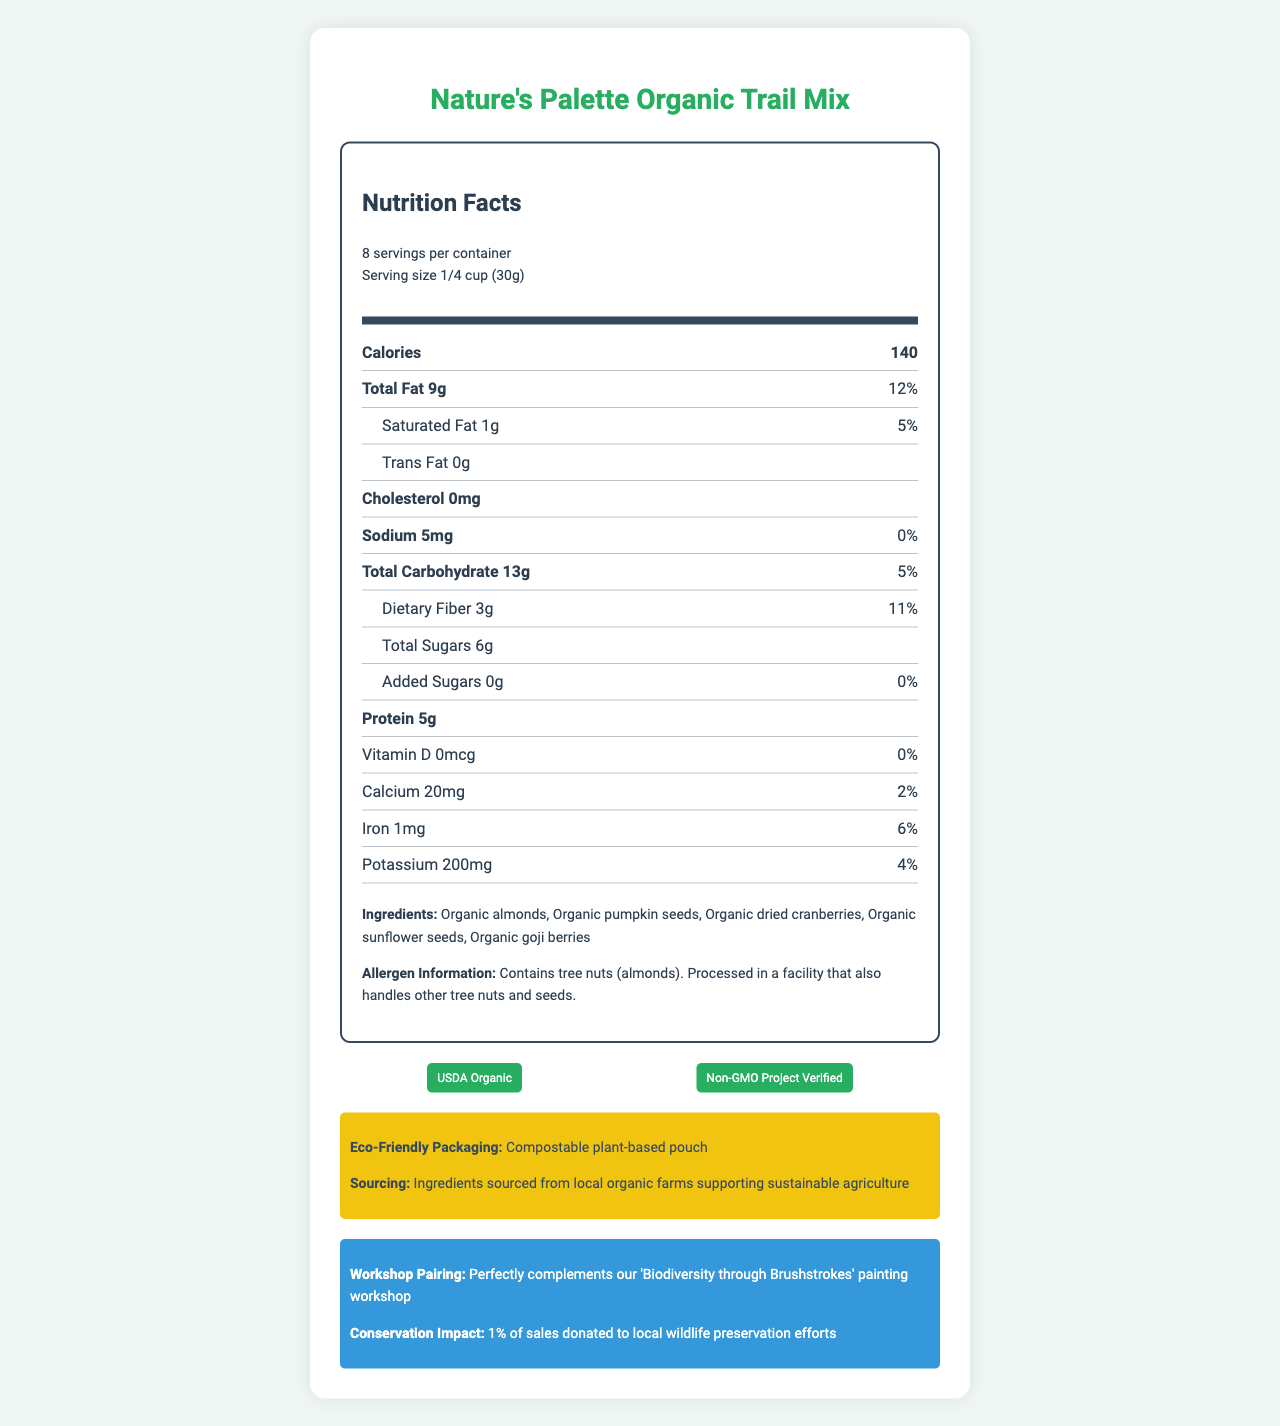what is the serving size? The serving size is listed at the beginning of the nutrition information under the product name.
Answer: 1/4 cup (30g) how many servings are in one container? The number of servings per container is listed in the serving information.
Answer: 8 how many grams of protein are in one serving? The protein content per serving is listed in the nutrition facts section.
Answer: 5g what percentage of the daily value of total fat is in one serving? The percentage of the daily value for total fat is listed in the nutrition facts section next to the amount.
Answer: 12% is there any cholesterol in the product? The nutrition facts state that cholesterol is 0mg.
Answer: No what are the ingredients in this trail mix? The ingredients are listed toward the bottom of the document under the ingredients section.
Answer: Organic almonds, Organic pumpkin seeds, Organic dried cranberries, Organic sunflower seeds, Organic goji berries which of the following nutrients has the highest daily value percentage per serving? A. Saturated Fat B. Dietary Fiber C. Potassium D. Iron Dietary Fiber has a daily value percentage of 11%, which is higher than the other listed nutrients.
Answer: A. Dietary Fiber how much calcium does one serving provide? A. 0mg B. 10mg C. 20mg D. 30mg The nutrition facts section lists the calcium content, which is 20mg per serving.
Answer: C. 20mg what certifications does this product have? The certifications are listed at the bottom of the document in the certifications section.
Answer: USDA Organic, Non-GMO Project Verified does this product contain added sugars? The document states that added sugars are 0g.
Answer: No is the packaging eco-friendly? The document mentions that the product comes in a compostable plant-based pouch in the eco-friendly packaging section.
Answer: Yes how much potassium is in one serving? The potassium content per serving is listed in the nutrition facts section.
Answer: 200mg can you determine the price of the product from the document? The document does not provide any information about the price of the product.
Answer: No summarize the document. This summary covers the main aspects of the document, including the nutritional facts, ingredients, certifications, eco-friendly packaging, workshop pairing, and conservation efforts.
Answer: The document is a nutrition facts label for "Nature's Palette Organic Trail Mix." It includes nutritional information for a serving size of 1/4 cup, with 8 servings per container. Key nutritional values include 140 calories, 9g of total fat, 5g of protein, and various vitamins and minerals. The ingredients list consists of organic nuts, seeds, and dried fruits. The product is certified USDA Organic and Non-GMO Project Verified, uses eco-friendly packaging, and supports nature conservation efforts. It also highlights allergen information and suggests pairing with a specific painting workshop. what is the daily value percentage of iron in one serving? The nutrition facts section lists the daily value percentage of iron next to its amount.
Answer: 6% 